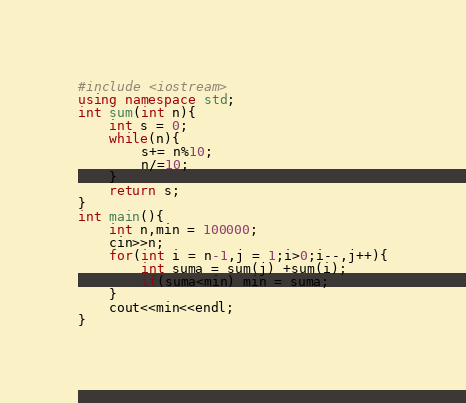<code> <loc_0><loc_0><loc_500><loc_500><_C++_>#include <iostream>
using namespace std;
int sum(int n){
	int s = 0;
	while(n){
		s+= n%10;
		n/=10;
	}
	return s;
}
int main(){
	int n,min = 100000;
	cin>>n;
	for(int i = n-1,j = 1;i>0;i--,j++){
		int suma = sum(j) +sum(i); 
		if(suma<min) min = suma;
	}
	cout<<min<<endl;
}</code> 